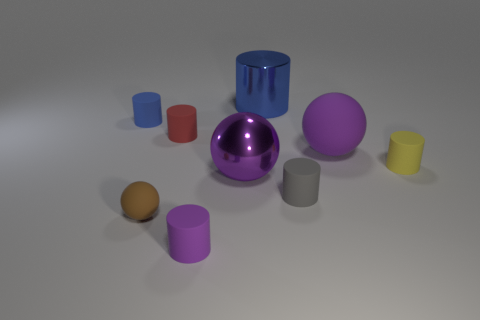Are there fewer small cylinders than purple metallic cubes?
Your answer should be very brief. No. Is there any other thing that is the same color as the tiny rubber ball?
Make the answer very short. No. What shape is the large object that is behind the large rubber ball?
Ensure brevity in your answer.  Cylinder. Is the color of the metallic cylinder the same as the small cylinder left of the tiny brown matte ball?
Offer a very short reply. Yes. Are there an equal number of brown rubber things that are behind the gray matte object and purple rubber cylinders right of the brown matte object?
Offer a terse response. No. What number of other objects are the same size as the shiny cylinder?
Make the answer very short. 2. The purple matte sphere has what size?
Offer a terse response. Large. Do the small gray cylinder and the blue object on the right side of the red thing have the same material?
Make the answer very short. No. Are there any green rubber objects that have the same shape as the red thing?
Your response must be concise. No. There is a brown ball that is the same size as the gray thing; what is its material?
Your response must be concise. Rubber. 